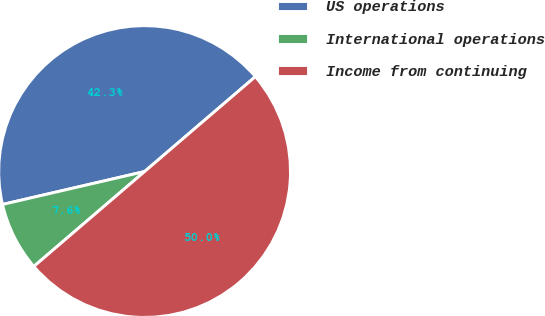Convert chart. <chart><loc_0><loc_0><loc_500><loc_500><pie_chart><fcel>US operations<fcel>International operations<fcel>Income from continuing<nl><fcel>42.35%<fcel>7.65%<fcel>50.0%<nl></chart> 